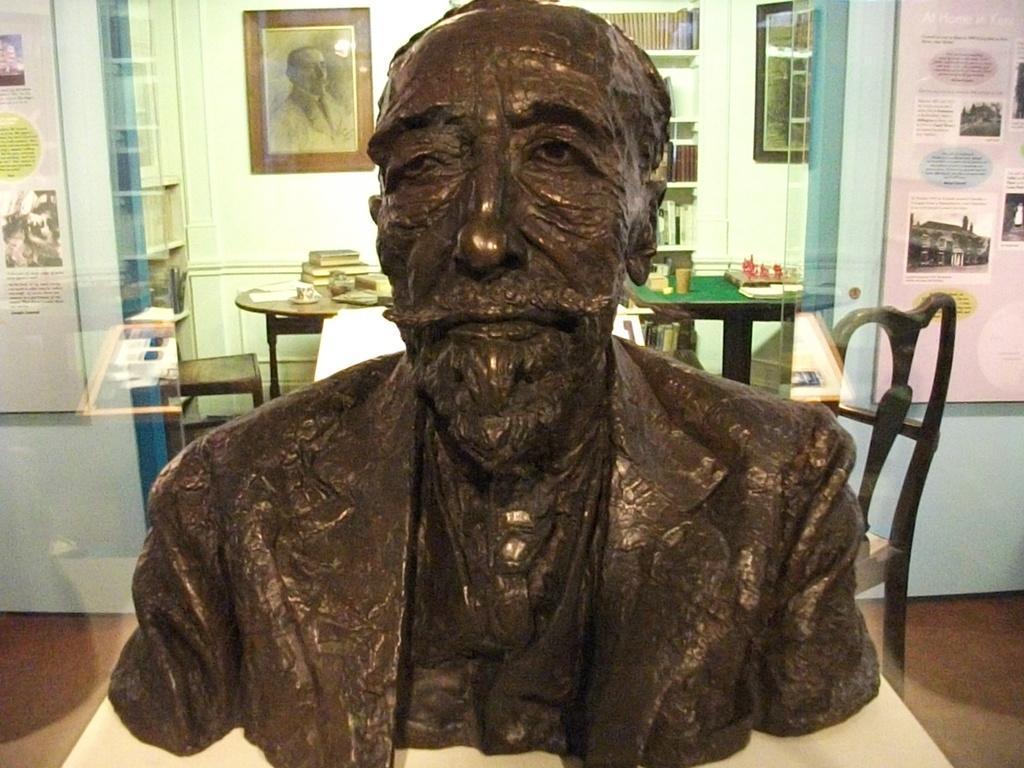Can you describe this image briefly? This is a statue of a person kept on a table. There are chairs. In the background a table is there. Books and cup and saucer is kept on the table. In the wall there are photo frame. Books are kept on the shelves. 